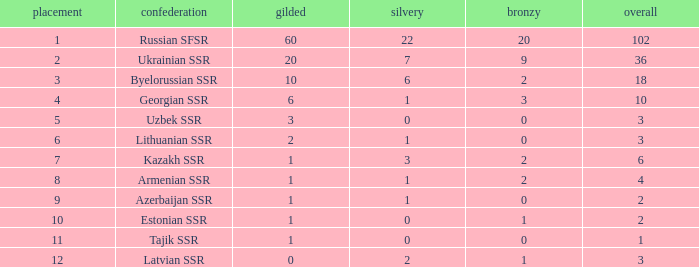What is the total number of bronzes associated with 1 silver, ranks under 6 and under 6 golds? None. 